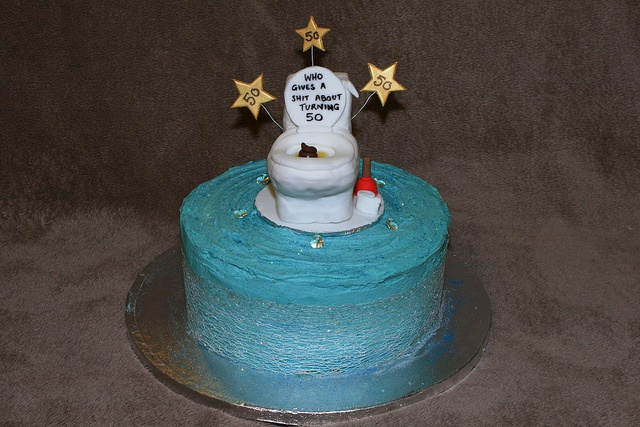Describe the objects in this image and their specific colors. I can see cake in black and teal tones and toilet in black, lightgray, and darkgray tones in this image. 